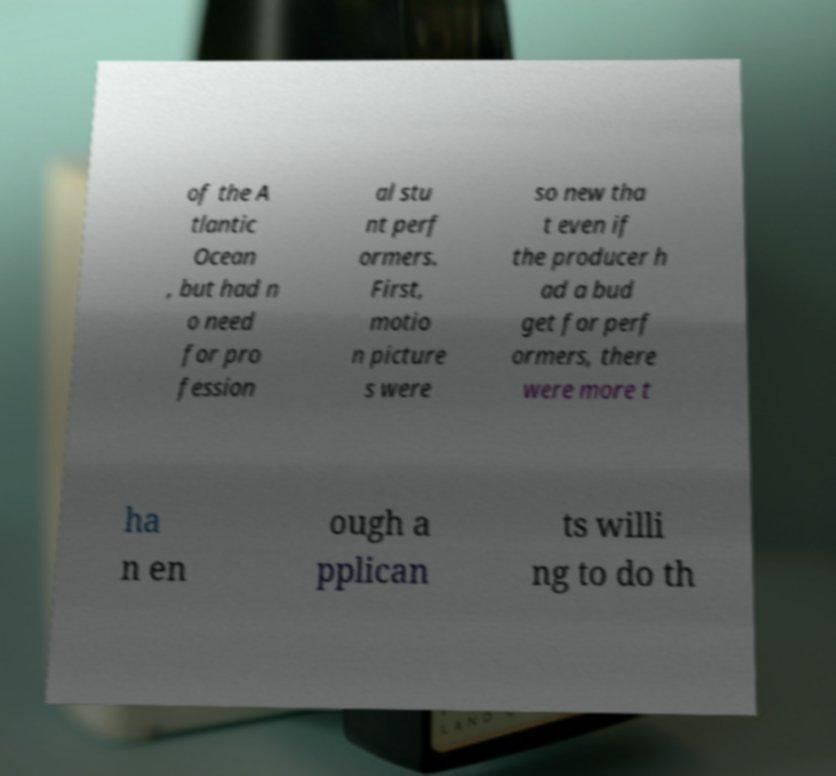There's text embedded in this image that I need extracted. Can you transcribe it verbatim? of the A tlantic Ocean , but had n o need for pro fession al stu nt perf ormers. First, motio n picture s were so new tha t even if the producer h ad a bud get for perf ormers, there were more t ha n en ough a pplican ts willi ng to do th 